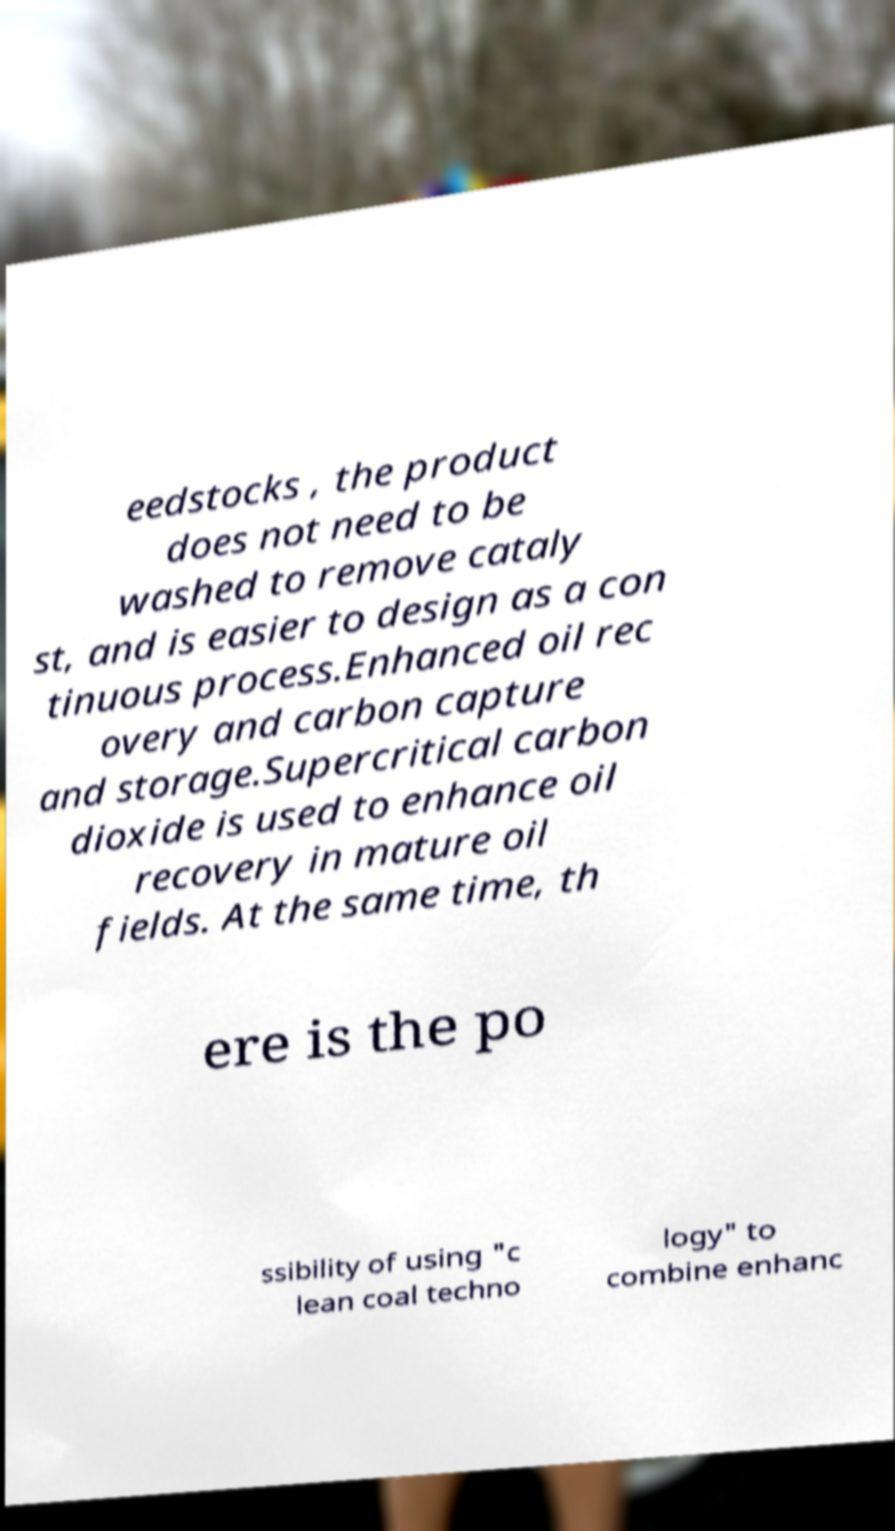Could you extract and type out the text from this image? eedstocks , the product does not need to be washed to remove cataly st, and is easier to design as a con tinuous process.Enhanced oil rec overy and carbon capture and storage.Supercritical carbon dioxide is used to enhance oil recovery in mature oil fields. At the same time, th ere is the po ssibility of using "c lean coal techno logy" to combine enhanc 